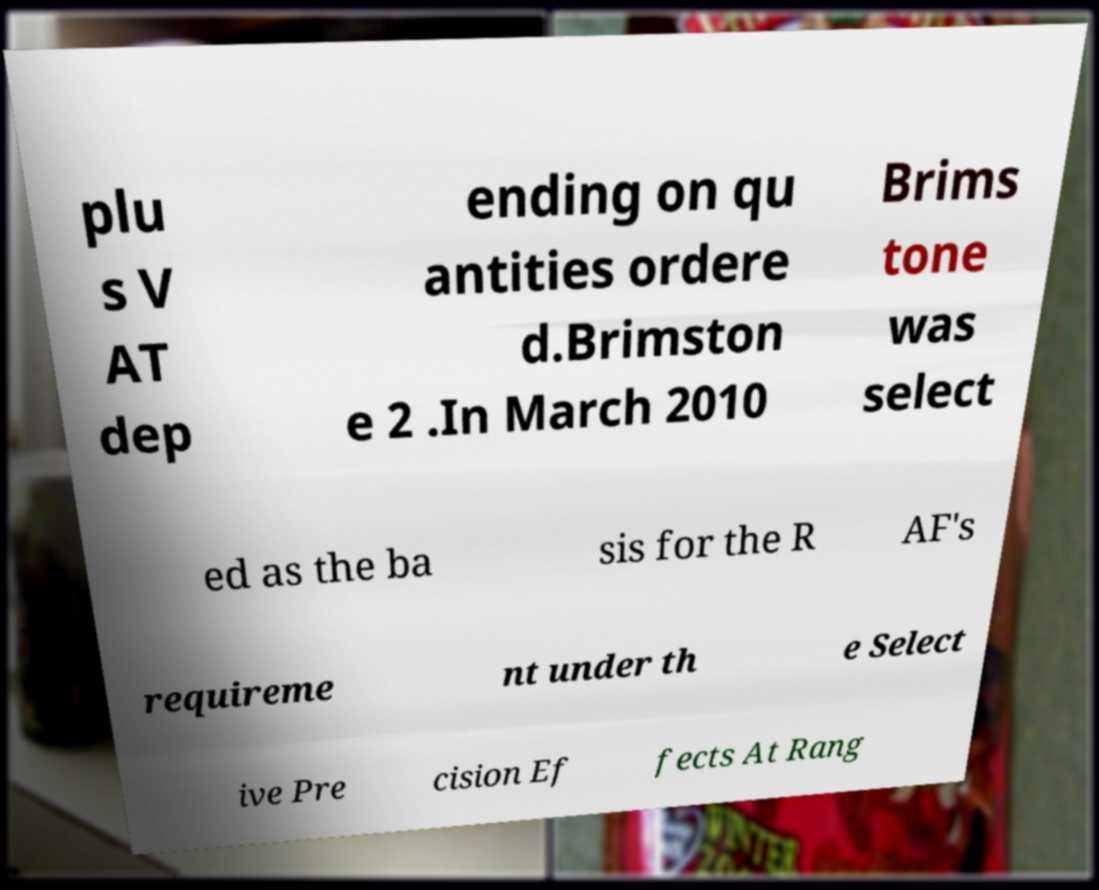I need the written content from this picture converted into text. Can you do that? plu s V AT dep ending on qu antities ordere d.Brimston e 2 .In March 2010 Brims tone was select ed as the ba sis for the R AF's requireme nt under th e Select ive Pre cision Ef fects At Rang 